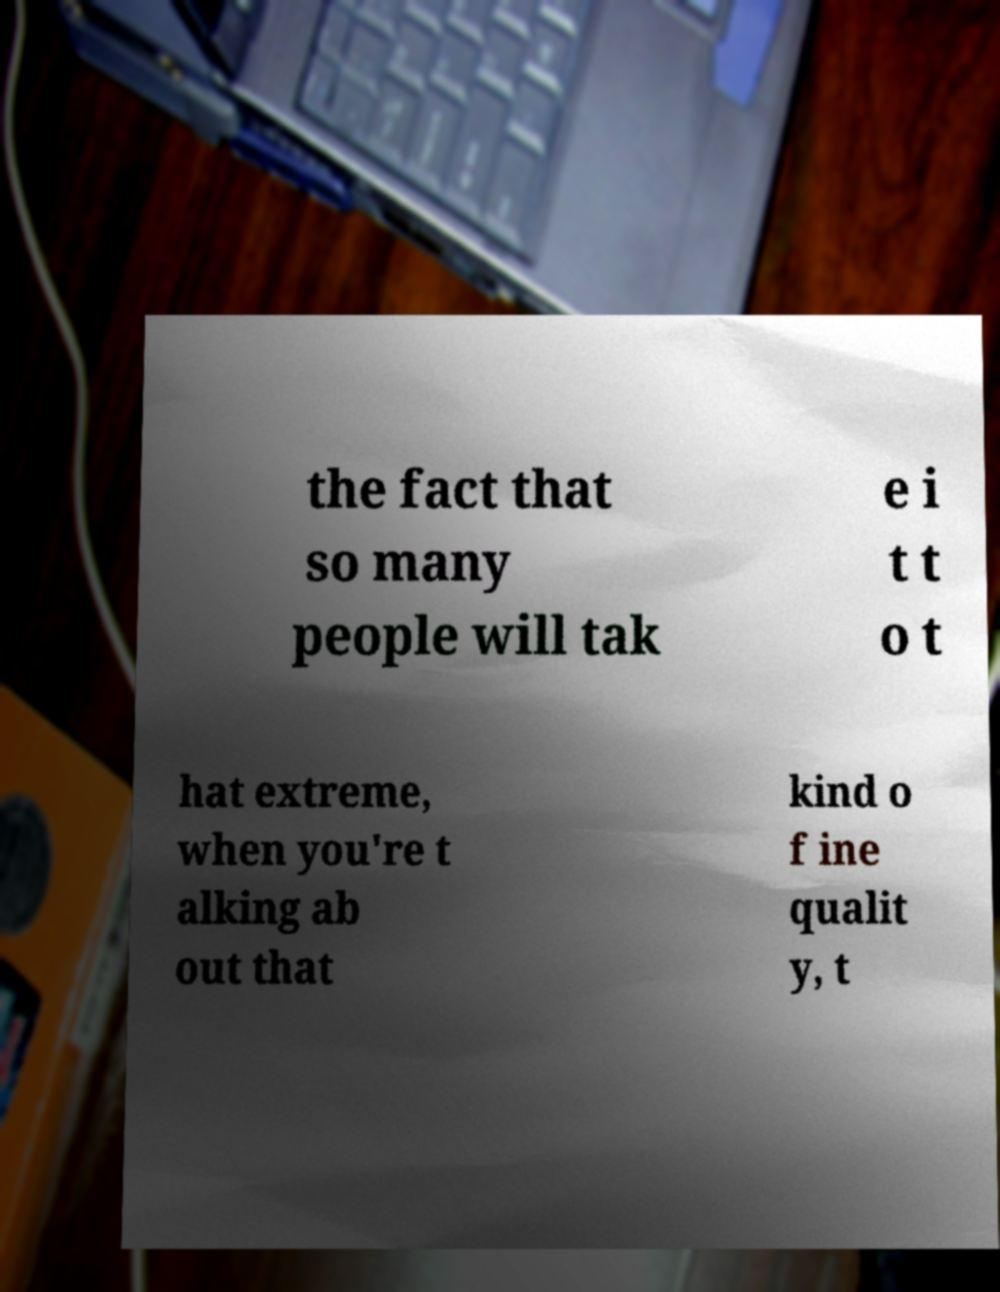I need the written content from this picture converted into text. Can you do that? the fact that so many people will tak e i t t o t hat extreme, when you're t alking ab out that kind o f ine qualit y, t 